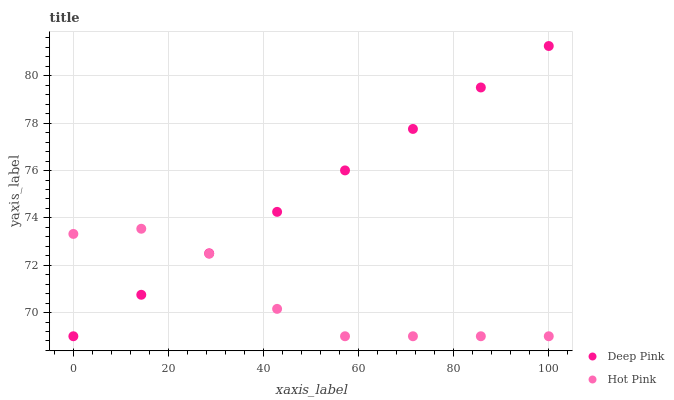Does Hot Pink have the minimum area under the curve?
Answer yes or no. Yes. Does Deep Pink have the maximum area under the curve?
Answer yes or no. Yes. Does Hot Pink have the maximum area under the curve?
Answer yes or no. No. Is Deep Pink the smoothest?
Answer yes or no. Yes. Is Hot Pink the roughest?
Answer yes or no. Yes. Is Hot Pink the smoothest?
Answer yes or no. No. Does Deep Pink have the lowest value?
Answer yes or no. Yes. Does Deep Pink have the highest value?
Answer yes or no. Yes. Does Hot Pink have the highest value?
Answer yes or no. No. Does Deep Pink intersect Hot Pink?
Answer yes or no. Yes. Is Deep Pink less than Hot Pink?
Answer yes or no. No. Is Deep Pink greater than Hot Pink?
Answer yes or no. No. 